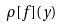Convert formula to latex. <formula><loc_0><loc_0><loc_500><loc_500>\rho [ f ] ( y )</formula> 